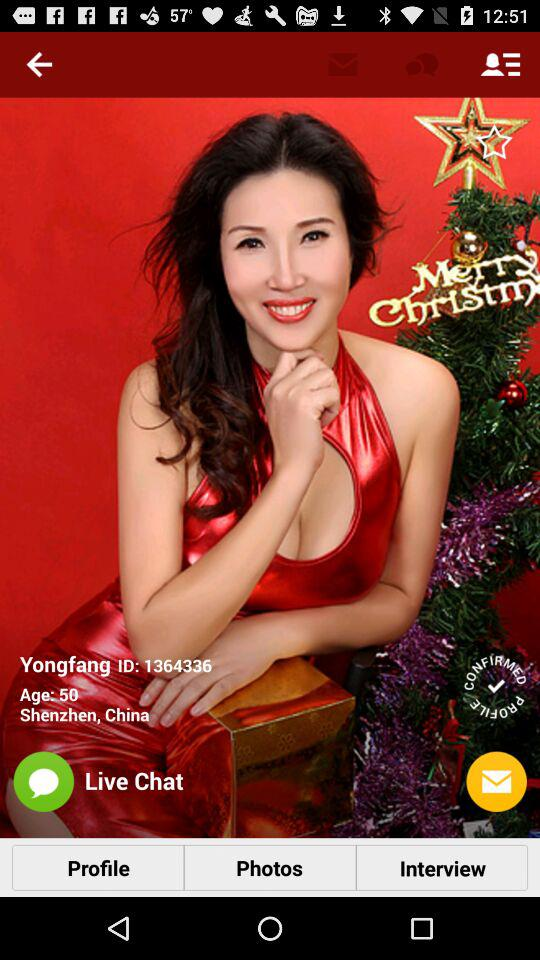What is the name of the user? The name of the user is Yongfang. 